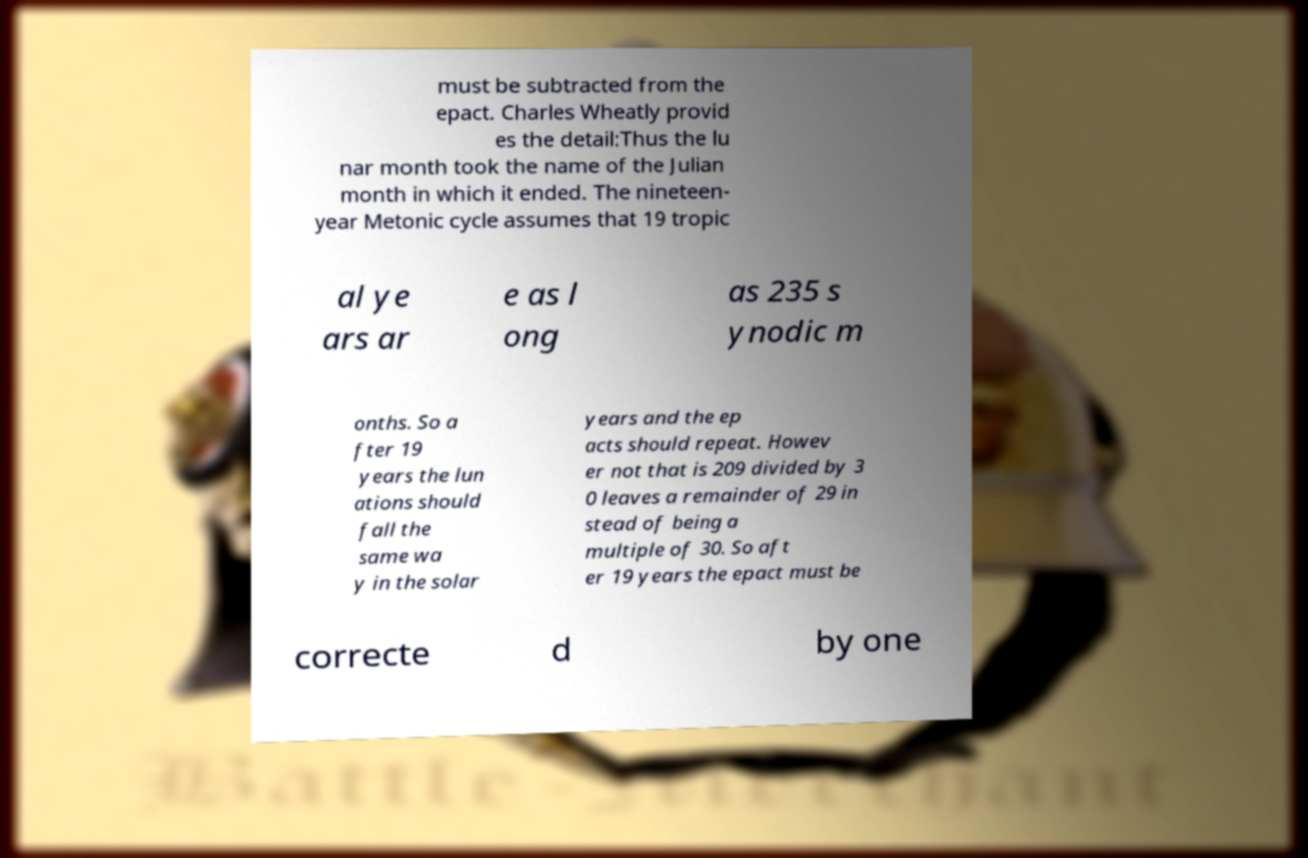Please identify and transcribe the text found in this image. must be subtracted from the epact. Charles Wheatly provid es the detail:Thus the lu nar month took the name of the Julian month in which it ended. The nineteen- year Metonic cycle assumes that 19 tropic al ye ars ar e as l ong as 235 s ynodic m onths. So a fter 19 years the lun ations should fall the same wa y in the solar years and the ep acts should repeat. Howev er not that is 209 divided by 3 0 leaves a remainder of 29 in stead of being a multiple of 30. So aft er 19 years the epact must be correcte d by one 